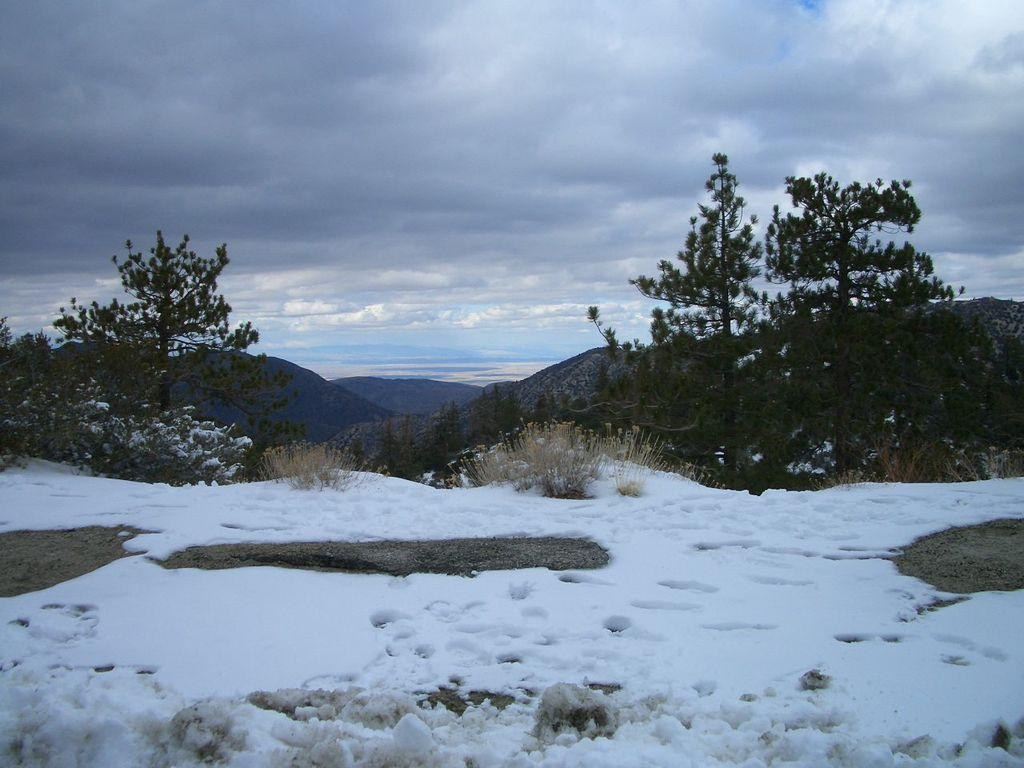What type of weather condition is depicted in the image? There is snow in the image, which suggests a wintery scene. What can be seen in the background of the image? There are plants and mountains in the background of the image. What is the color of the sky in the image? The sky is visible in the image, with a combination of white and blue colors. What type of cabbage is growing on the mountains in the image? There are no cabbages visible in the image, and the mountains are not depicted as having any vegetation growing on them. --- Facts: 1. There is a person sitting on a chair in the image. 2. The person is holding a book. 3. The book has a red cover. 4. There is a table next to the chair. 5. There is a lamp on the table. Absurd Topics: dance, ocean, parrot Conversation: What is the person in the image doing? The person is sitting on a chair in the image. What is the person holding in the image? The person is holding a book in the image. What is the color of the book's cover? The book has a red cover. What is located next to the chair in the image? There is a table next to the chair in the image. What is on the table in the image? There is a lamp on the table in the image. Reasoning: Let's think step by step in order to produce the conversation. We start by identifying the main subject in the image, which is the person sitting on a chair. Then, we expand the conversation to include other items that are also visible, such as the book, the table, and the lamp. Each question is designed to elicit a specific detail about the image that is known from the provided facts. Absurd Question/Answer: Can you see any parrots dancing in the ocean in the image? There are no parrots or ocean present in the image; it features a person sitting on a chair holding a book. 